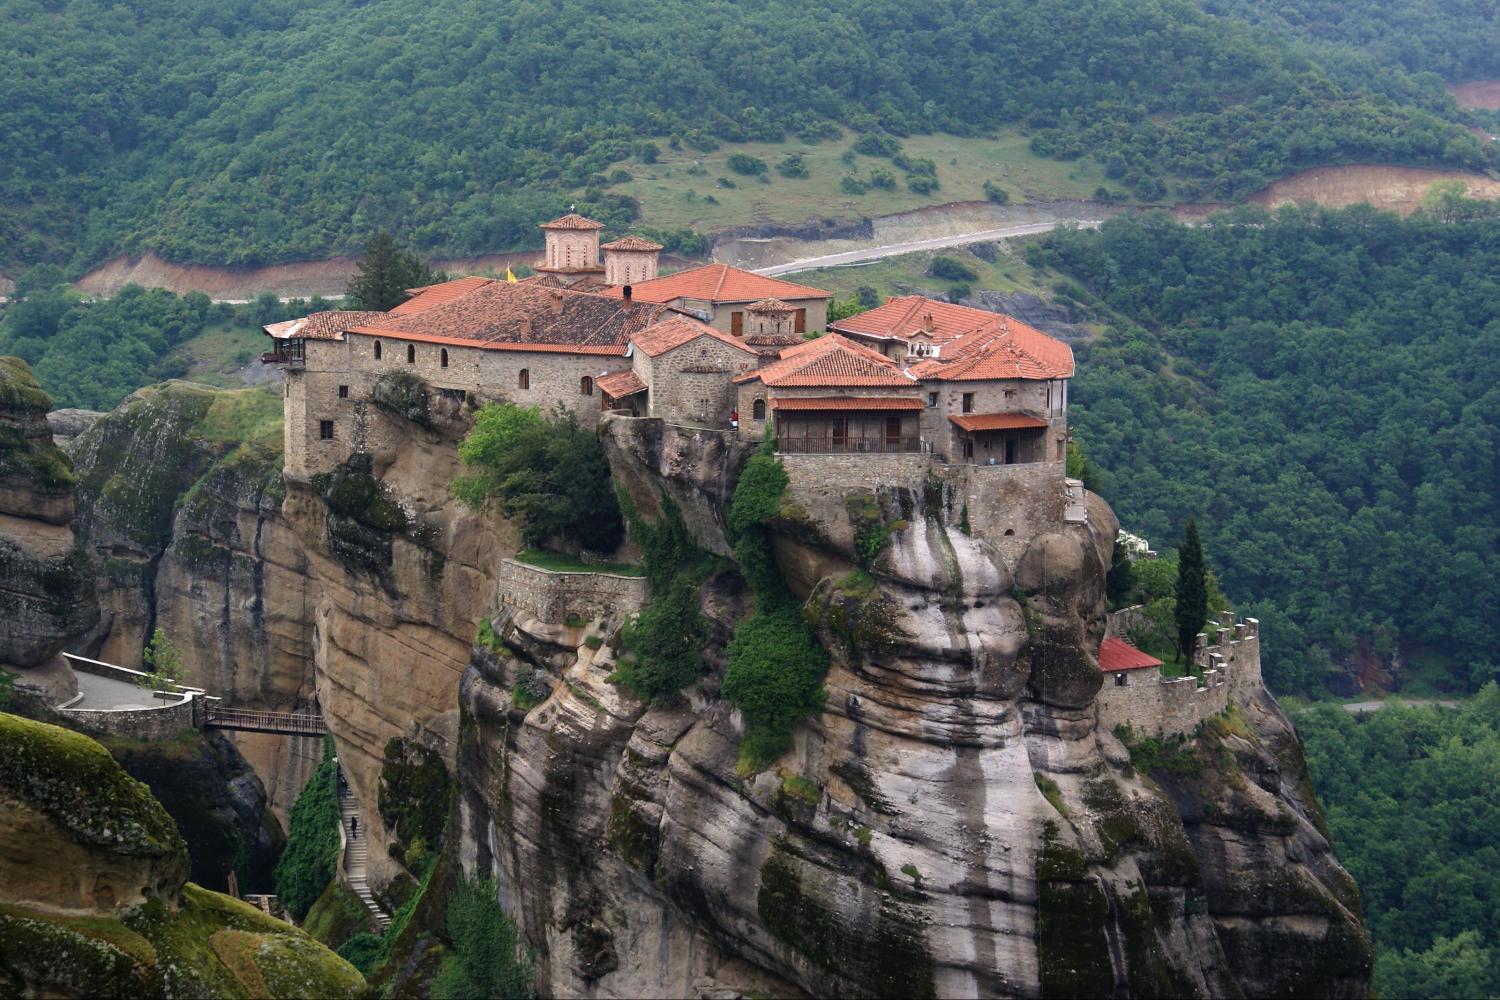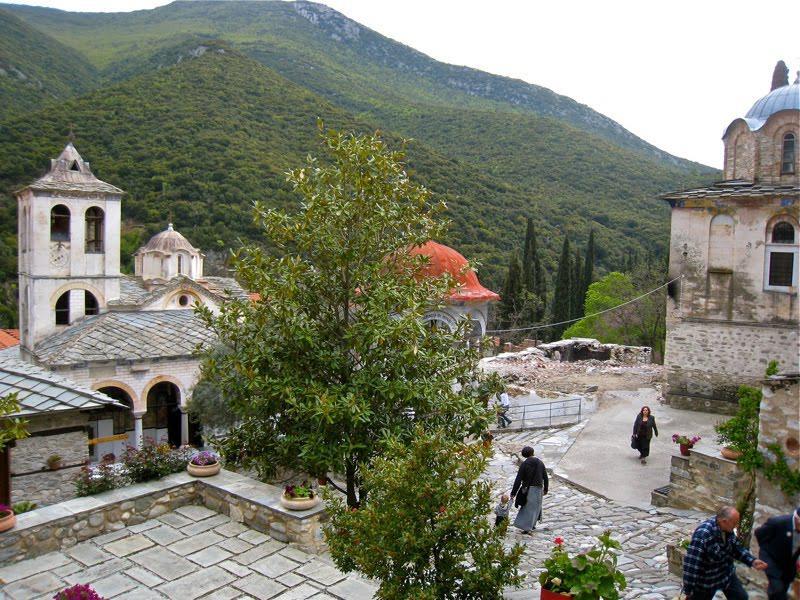The first image is the image on the left, the second image is the image on the right. For the images displayed, is the sentence "We see at least one mansion, built onto a skinny cliff; there certainly isn't enough room for a town." factually correct? Answer yes or no. Yes. The first image is the image on the left, the second image is the image on the right. Examine the images to the left and right. Is the description "There are a set of red brick topped buildings sitting on the edge of a cliff." accurate? Answer yes or no. Yes. 